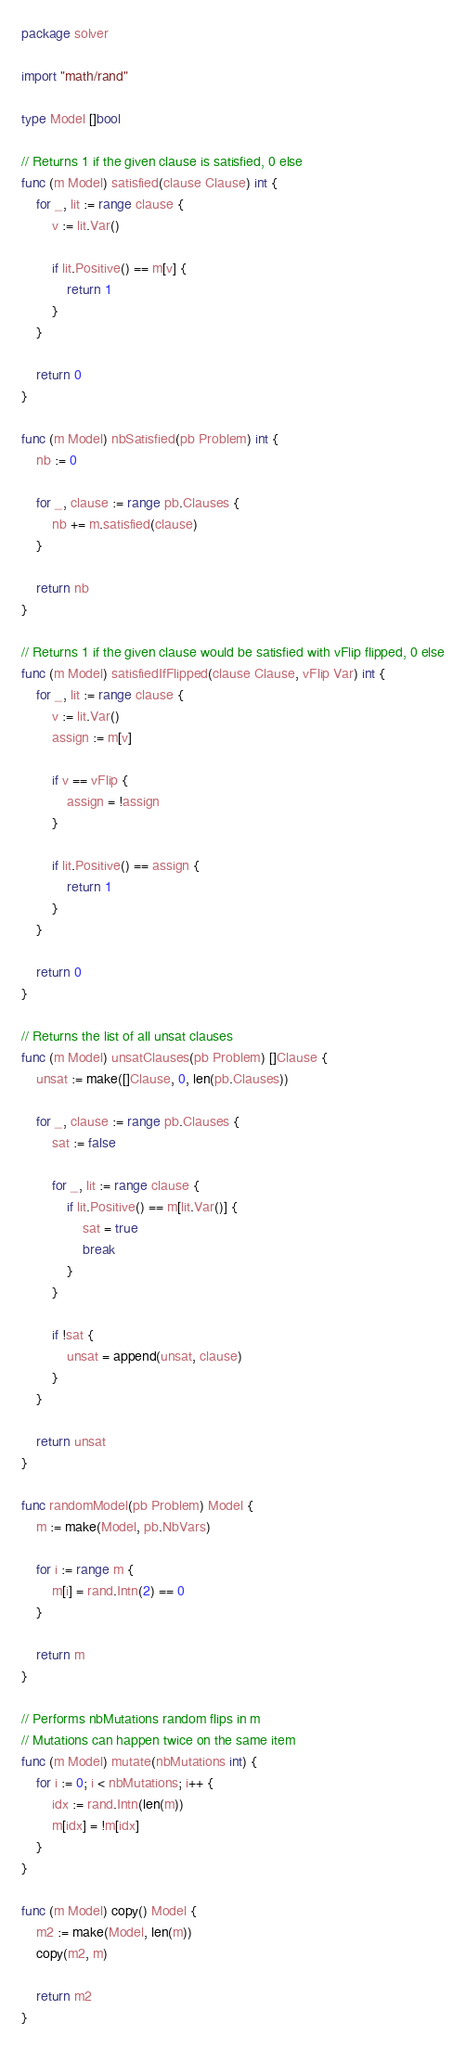<code> <loc_0><loc_0><loc_500><loc_500><_Go_>package solver

import "math/rand"

type Model []bool

// Returns 1 if the given clause is satisfied, 0 else
func (m Model) satisfied(clause Clause) int {
	for _, lit := range clause {
		v := lit.Var()

		if lit.Positive() == m[v] {
			return 1
		}
	}

	return 0
}

func (m Model) nbSatisfied(pb Problem) int {
	nb := 0

	for _, clause := range pb.Clauses {
		nb += m.satisfied(clause)
	}

	return nb
}

// Returns 1 if the given clause would be satisfied with vFlip flipped, 0 else
func (m Model) satisfiedIfFlipped(clause Clause, vFlip Var) int {
	for _, lit := range clause {
		v := lit.Var()
		assign := m[v]

		if v == vFlip {
			assign = !assign
		}

		if lit.Positive() == assign {
			return 1
		}
	}

	return 0
}

// Returns the list of all unsat clauses
func (m Model) unsatClauses(pb Problem) []Clause {
	unsat := make([]Clause, 0, len(pb.Clauses))

	for _, clause := range pb.Clauses {
		sat := false

		for _, lit := range clause {
			if lit.Positive() == m[lit.Var()] {
				sat = true
				break
			}
		}

		if !sat {
			unsat = append(unsat, clause)
		}
	}

	return unsat
}

func randomModel(pb Problem) Model {
	m := make(Model, pb.NbVars)

	for i := range m {
		m[i] = rand.Intn(2) == 0
	}

	return m
}

// Performs nbMutations random flips in m
// Mutations can happen twice on the same item
func (m Model) mutate(nbMutations int) {
	for i := 0; i < nbMutations; i++ {
		idx := rand.Intn(len(m))
		m[idx] = !m[idx]
	}
}

func (m Model) copy() Model {
	m2 := make(Model, len(m))
	copy(m2, m)

	return m2
}
</code> 